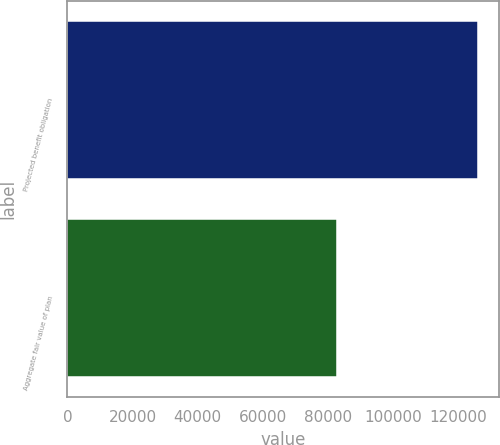Convert chart. <chart><loc_0><loc_0><loc_500><loc_500><bar_chart><fcel>Projected benefit obligation<fcel>Aggregate fair value of plan<nl><fcel>126031<fcel>82852<nl></chart> 